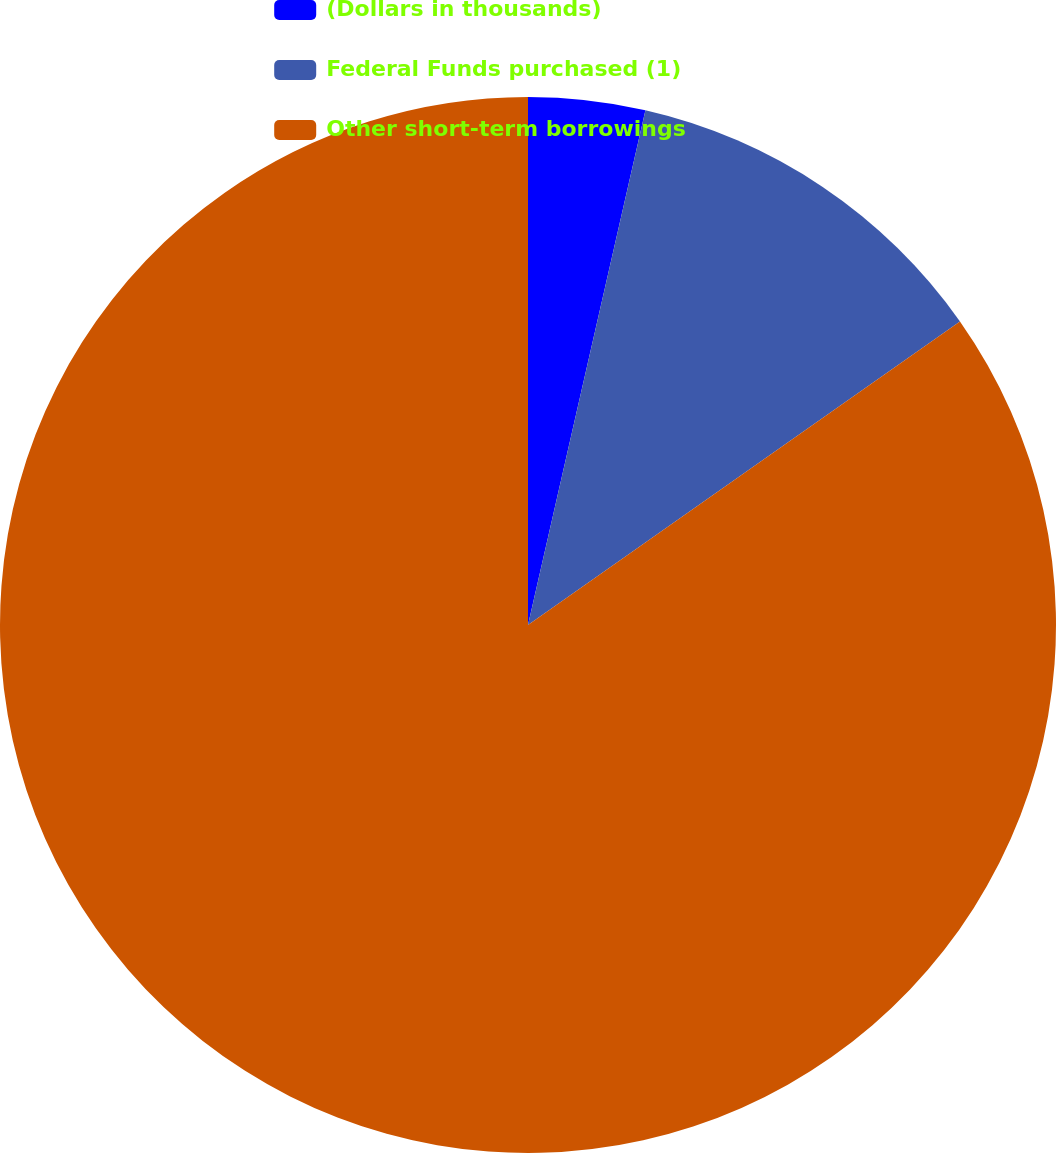Convert chart to OTSL. <chart><loc_0><loc_0><loc_500><loc_500><pie_chart><fcel>(Dollars in thousands)<fcel>Federal Funds purchased (1)<fcel>Other short-term borrowings<nl><fcel>3.57%<fcel>11.68%<fcel>84.75%<nl></chart> 